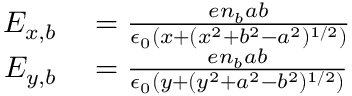<formula> <loc_0><loc_0><loc_500><loc_500>\begin{array} { r l } { E _ { x , b } } & = \frac { e n _ { b } a b } { \epsilon _ { 0 } ( x + ( x ^ { 2 } + b ^ { 2 } - a ^ { 2 } ) ^ { 1 / 2 } ) } } \\ { E _ { y , b } } & = \frac { e n _ { b } a b } { \epsilon _ { 0 } ( y + ( y ^ { 2 } + a ^ { 2 } - b ^ { 2 } ) ^ { 1 / 2 } ) } } \end{array}</formula> 